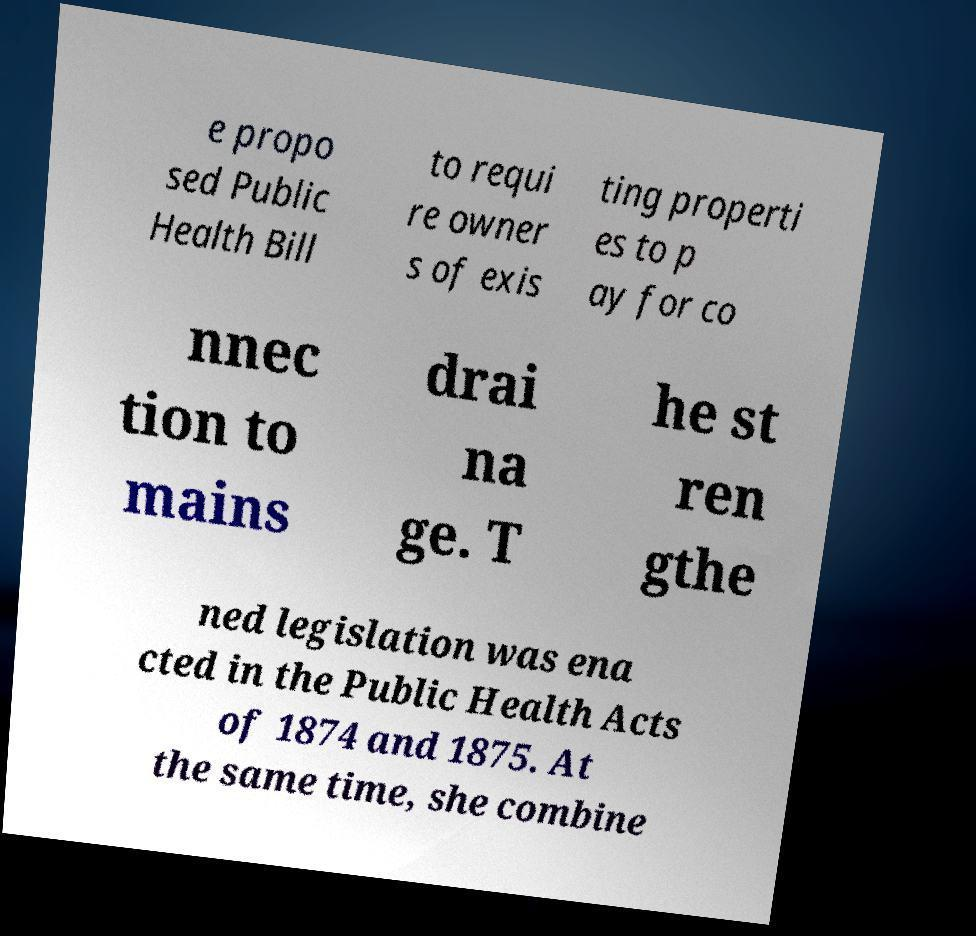Could you assist in decoding the text presented in this image and type it out clearly? e propo sed Public Health Bill to requi re owner s of exis ting properti es to p ay for co nnec tion to mains drai na ge. T he st ren gthe ned legislation was ena cted in the Public Health Acts of 1874 and 1875. At the same time, she combine 